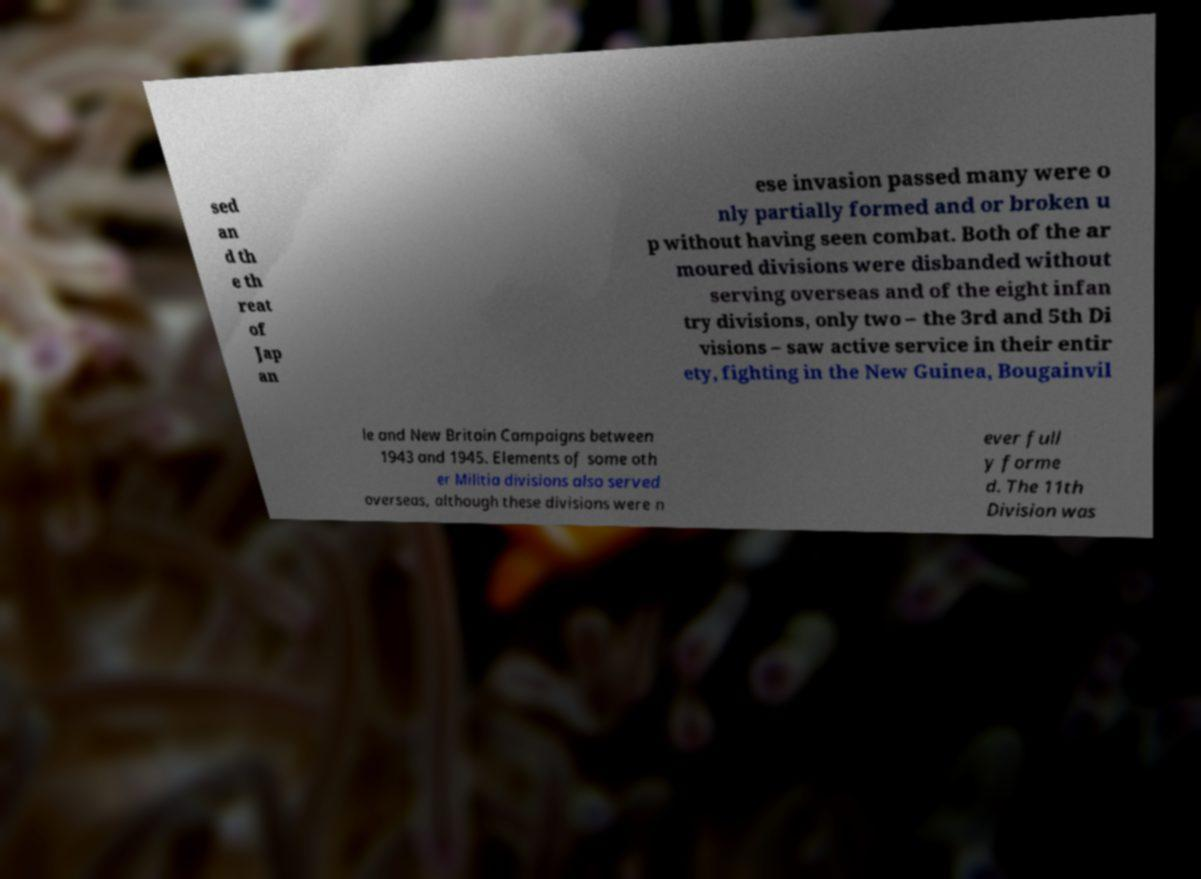Can you accurately transcribe the text from the provided image for me? sed an d th e th reat of Jap an ese invasion passed many were o nly partially formed and or broken u p without having seen combat. Both of the ar moured divisions were disbanded without serving overseas and of the eight infan try divisions, only two – the 3rd and 5th Di visions – saw active service in their entir ety, fighting in the New Guinea, Bougainvil le and New Britain Campaigns between 1943 and 1945. Elements of some oth er Militia divisions also served overseas, although these divisions were n ever full y forme d. The 11th Division was 